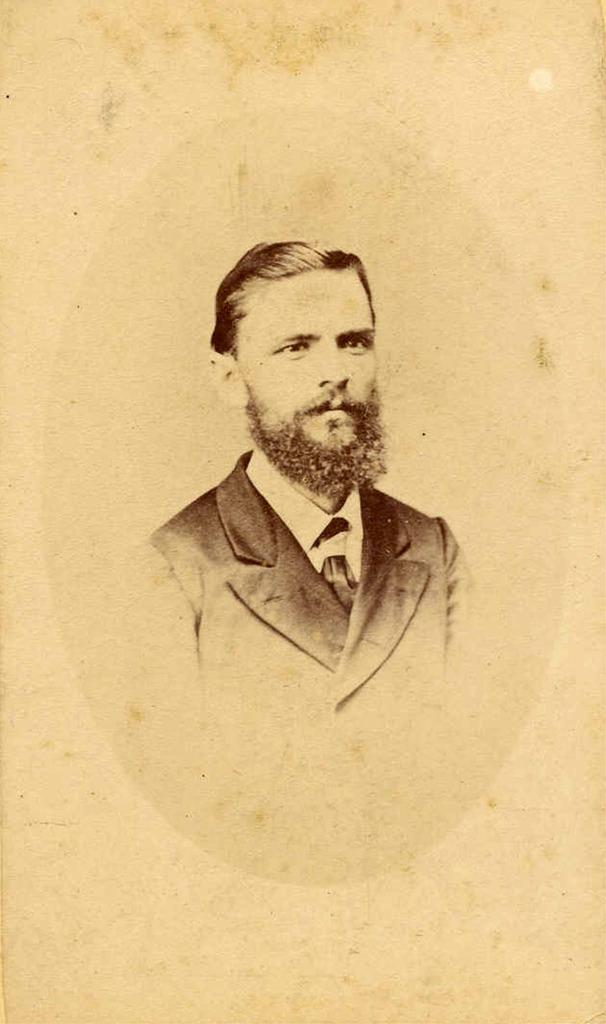Who is the person in the image? There is a man in the image. What is the man wearing? The man is wearing a suit, a shirt, and a tie. How many legs does the tie have in the image? Ties do not have legs; they are a piece of clothing worn around the neck. 